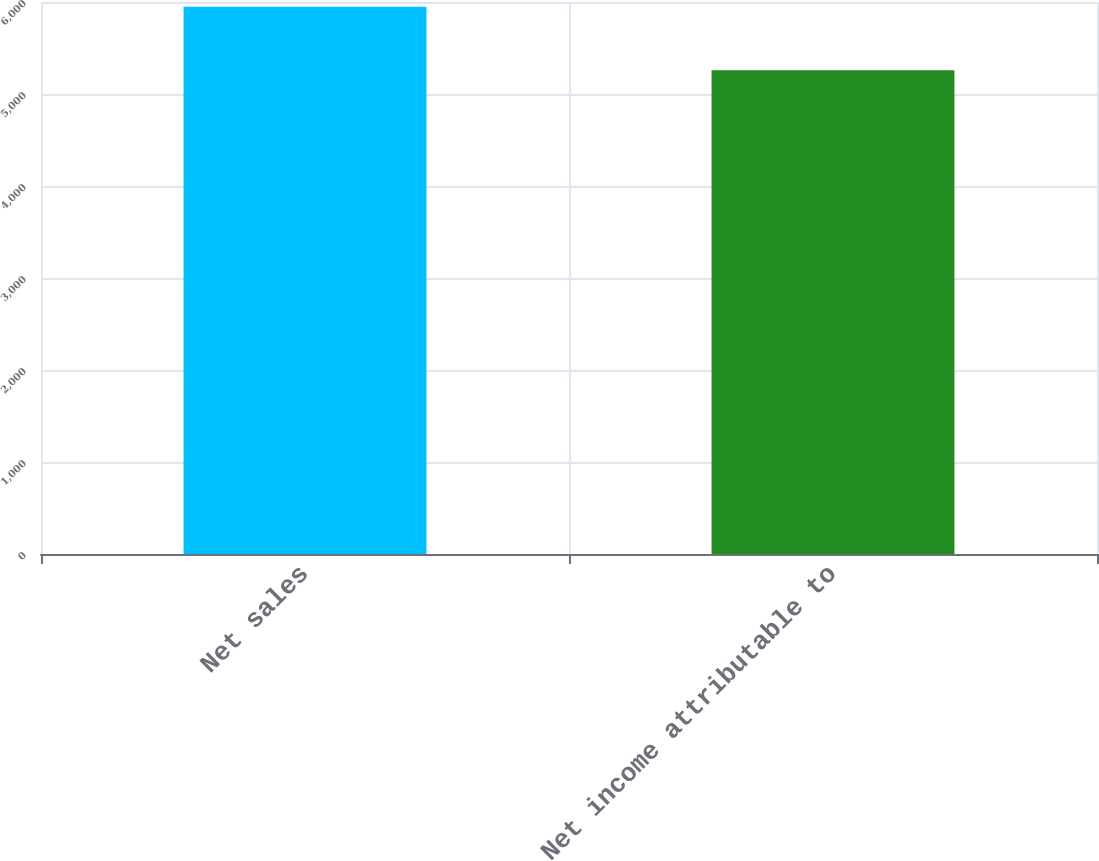<chart> <loc_0><loc_0><loc_500><loc_500><bar_chart><fcel>Net sales<fcel>Net income attributable to<nl><fcel>5948<fcel>5257<nl></chart> 